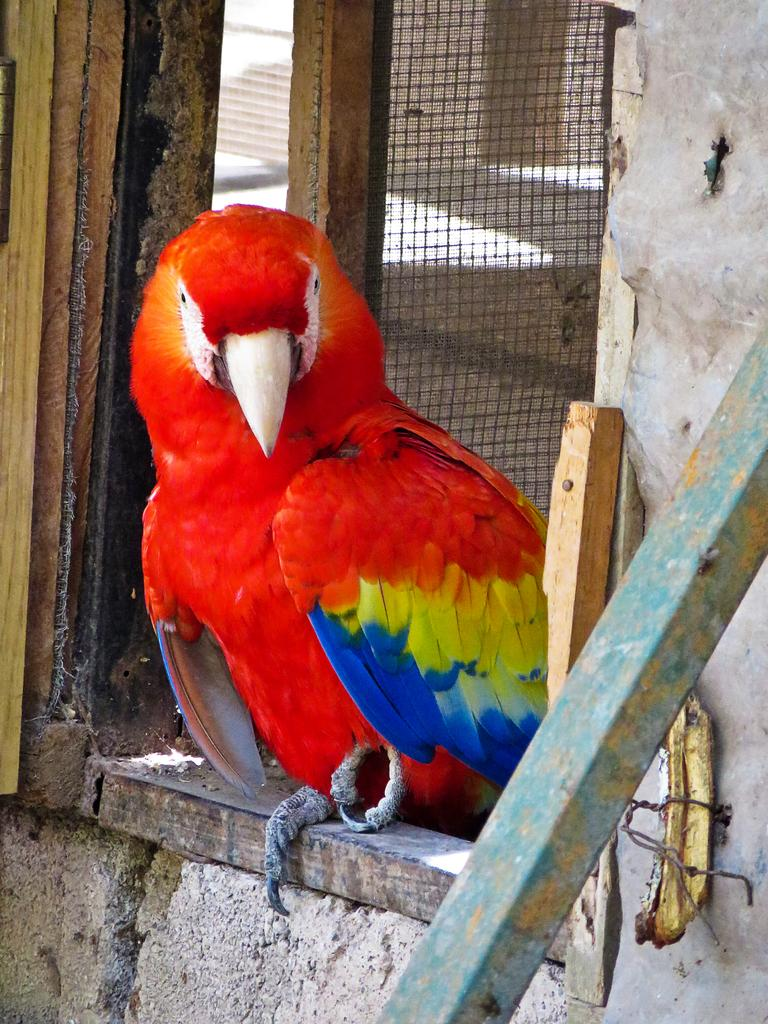What type of animal can be seen in the image? There is a bird in the image. Where is the bird located? The bird is standing on a wood wall. What can be seen in the background of the image? There is a net fence and a wood rod in the background of the image. What type of material is present on the right side of the image? There is a metal rod on the right side of the image. How many women are burning waste in the image? There are no women or waste present in the image. 